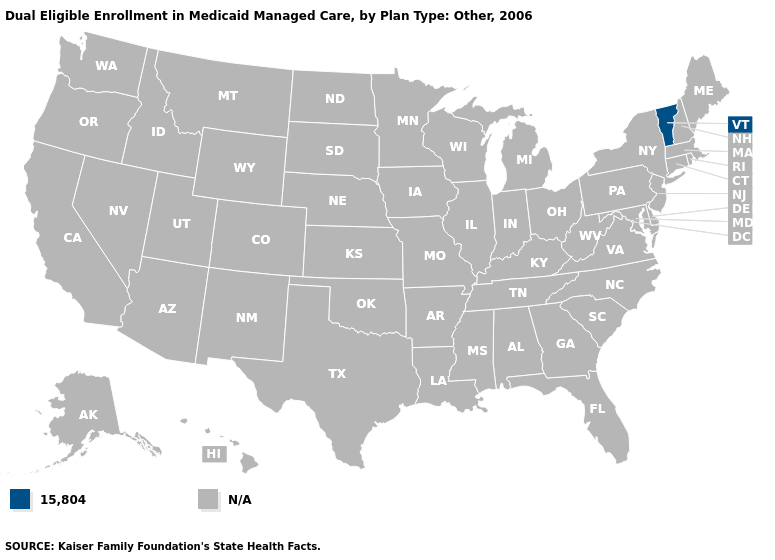Name the states that have a value in the range 15,804?
Quick response, please. Vermont. Is the legend a continuous bar?
Answer briefly. No. Name the states that have a value in the range 15,804?
Short answer required. Vermont. Name the states that have a value in the range N/A?
Write a very short answer. Alabama, Alaska, Arizona, Arkansas, California, Colorado, Connecticut, Delaware, Florida, Georgia, Hawaii, Idaho, Illinois, Indiana, Iowa, Kansas, Kentucky, Louisiana, Maine, Maryland, Massachusetts, Michigan, Minnesota, Mississippi, Missouri, Montana, Nebraska, Nevada, New Hampshire, New Jersey, New Mexico, New York, North Carolina, North Dakota, Ohio, Oklahoma, Oregon, Pennsylvania, Rhode Island, South Carolina, South Dakota, Tennessee, Texas, Utah, Virginia, Washington, West Virginia, Wisconsin, Wyoming. Name the states that have a value in the range N/A?
Give a very brief answer. Alabama, Alaska, Arizona, Arkansas, California, Colorado, Connecticut, Delaware, Florida, Georgia, Hawaii, Idaho, Illinois, Indiana, Iowa, Kansas, Kentucky, Louisiana, Maine, Maryland, Massachusetts, Michigan, Minnesota, Mississippi, Missouri, Montana, Nebraska, Nevada, New Hampshire, New Jersey, New Mexico, New York, North Carolina, North Dakota, Ohio, Oklahoma, Oregon, Pennsylvania, Rhode Island, South Carolina, South Dakota, Tennessee, Texas, Utah, Virginia, Washington, West Virginia, Wisconsin, Wyoming. What is the value of New York?
Give a very brief answer. N/A. What is the value of Maine?
Write a very short answer. N/A. 